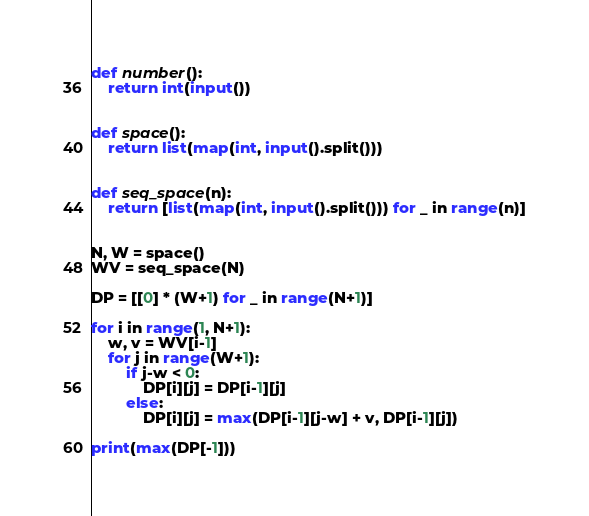Convert code to text. <code><loc_0><loc_0><loc_500><loc_500><_Python_>def number():
    return int(input())


def space():
    return list(map(int, input().split()))


def seq_space(n):
    return [list(map(int, input().split())) for _ in range(n)]


N, W = space()
WV = seq_space(N)

DP = [[0] * (W+1) for _ in range(N+1)]

for i in range(1, N+1):
    w, v = WV[i-1]
    for j in range(W+1):
        if j-w < 0:
            DP[i][j] = DP[i-1][j]
        else:
            DP[i][j] = max(DP[i-1][j-w] + v, DP[i-1][j])

print(max(DP[-1]))
</code> 